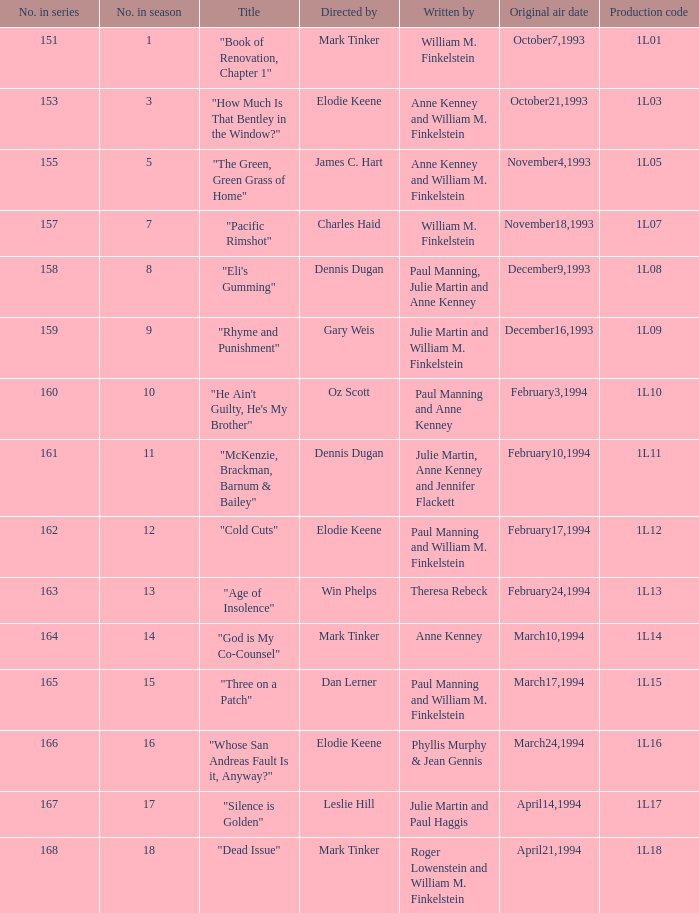Could you parse the entire table as a dict? {'header': ['No. in series', 'No. in season', 'Title', 'Directed by', 'Written by', 'Original air date', 'Production code'], 'rows': [['151', '1', '"Book of Renovation, Chapter 1"', 'Mark Tinker', 'William M. Finkelstein', 'October7,1993', '1L01'], ['153', '3', '"How Much Is That Bentley in the Window?"', 'Elodie Keene', 'Anne Kenney and William M. Finkelstein', 'October21,1993', '1L03'], ['155', '5', '"The Green, Green Grass of Home"', 'James C. Hart', 'Anne Kenney and William M. Finkelstein', 'November4,1993', '1L05'], ['157', '7', '"Pacific Rimshot"', 'Charles Haid', 'William M. Finkelstein', 'November18,1993', '1L07'], ['158', '8', '"Eli\'s Gumming"', 'Dennis Dugan', 'Paul Manning, Julie Martin and Anne Kenney', 'December9,1993', '1L08'], ['159', '9', '"Rhyme and Punishment"', 'Gary Weis', 'Julie Martin and William M. Finkelstein', 'December16,1993', '1L09'], ['160', '10', '"He Ain\'t Guilty, He\'s My Brother"', 'Oz Scott', 'Paul Manning and Anne Kenney', 'February3,1994', '1L10'], ['161', '11', '"McKenzie, Brackman, Barnum & Bailey"', 'Dennis Dugan', 'Julie Martin, Anne Kenney and Jennifer Flackett', 'February10,1994', '1L11'], ['162', '12', '"Cold Cuts"', 'Elodie Keene', 'Paul Manning and William M. Finkelstein', 'February17,1994', '1L12'], ['163', '13', '"Age of Insolence"', 'Win Phelps', 'Theresa Rebeck', 'February24,1994', '1L13'], ['164', '14', '"God is My Co-Counsel"', 'Mark Tinker', 'Anne Kenney', 'March10,1994', '1L14'], ['165', '15', '"Three on a Patch"', 'Dan Lerner', 'Paul Manning and William M. Finkelstein', 'March17,1994', '1L15'], ['166', '16', '"Whose San Andreas Fault Is it, Anyway?"', 'Elodie Keene', 'Phyllis Murphy & Jean Gennis', 'March24,1994', '1L16'], ['167', '17', '"Silence is Golden"', 'Leslie Hill', 'Julie Martin and Paul Haggis', 'April14,1994', '1L17'], ['168', '18', '"Dead Issue"', 'Mark Tinker', 'Roger Lowenstein and William M. Finkelstein', 'April21,1994', '1L18']]} State the original broadcast date for production code 1l1 March24,1994. 